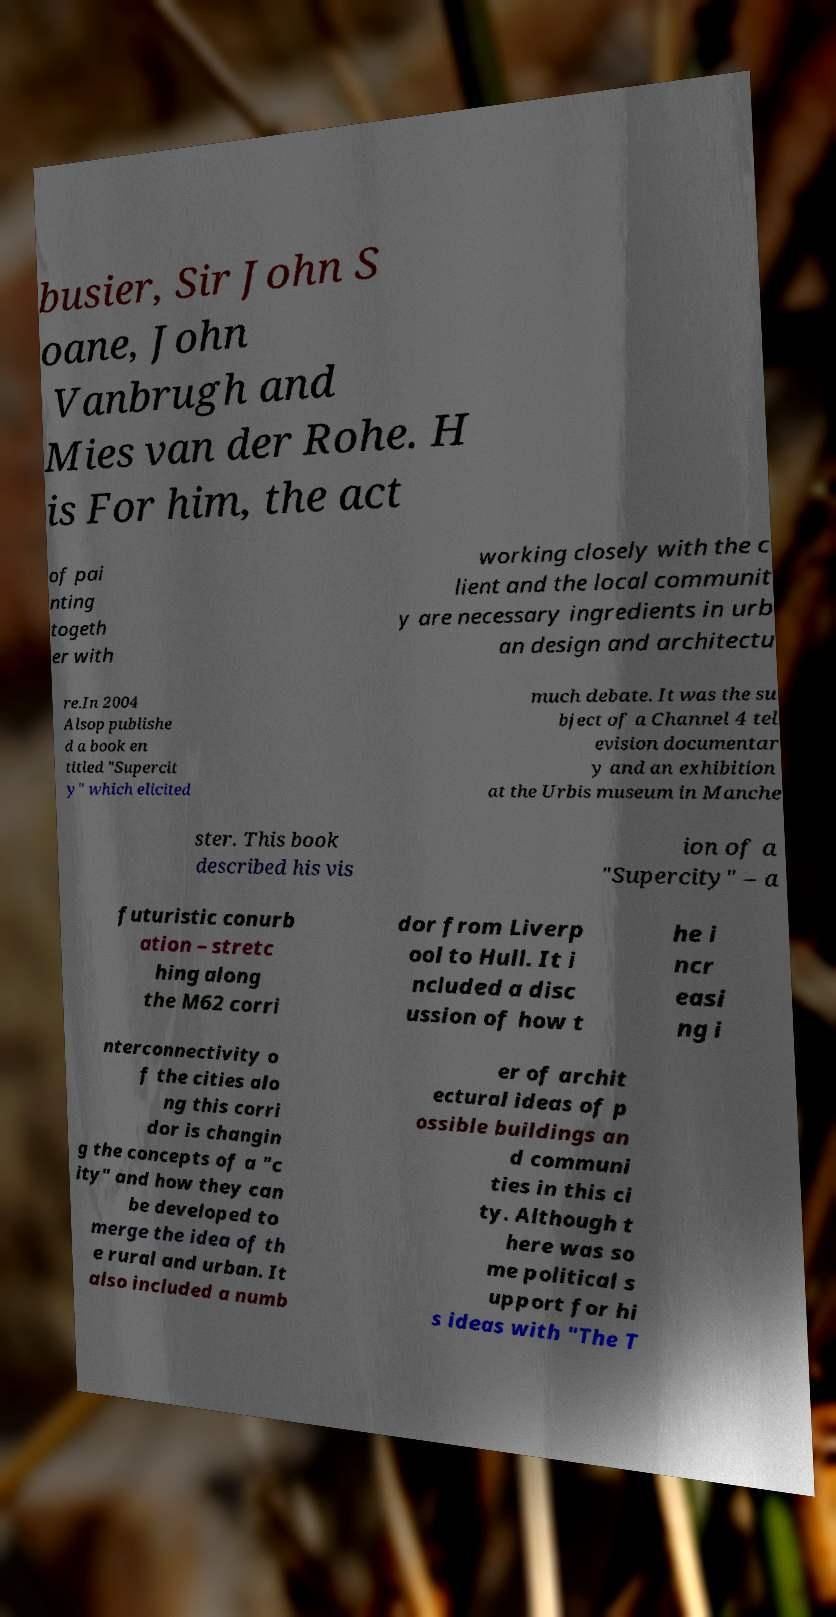Could you assist in decoding the text presented in this image and type it out clearly? busier, Sir John S oane, John Vanbrugh and Mies van der Rohe. H is For him, the act of pai nting togeth er with working closely with the c lient and the local communit y are necessary ingredients in urb an design and architectu re.In 2004 Alsop publishe d a book en titled "Supercit y" which elicited much debate. It was the su bject of a Channel 4 tel evision documentar y and an exhibition at the Urbis museum in Manche ster. This book described his vis ion of a "Supercity" – a futuristic conurb ation – stretc hing along the M62 corri dor from Liverp ool to Hull. It i ncluded a disc ussion of how t he i ncr easi ng i nterconnectivity o f the cities alo ng this corri dor is changin g the concepts of a "c ity" and how they can be developed to merge the idea of th e rural and urban. It also included a numb er of archit ectural ideas of p ossible buildings an d communi ties in this ci ty. Although t here was so me political s upport for hi s ideas with "The T 